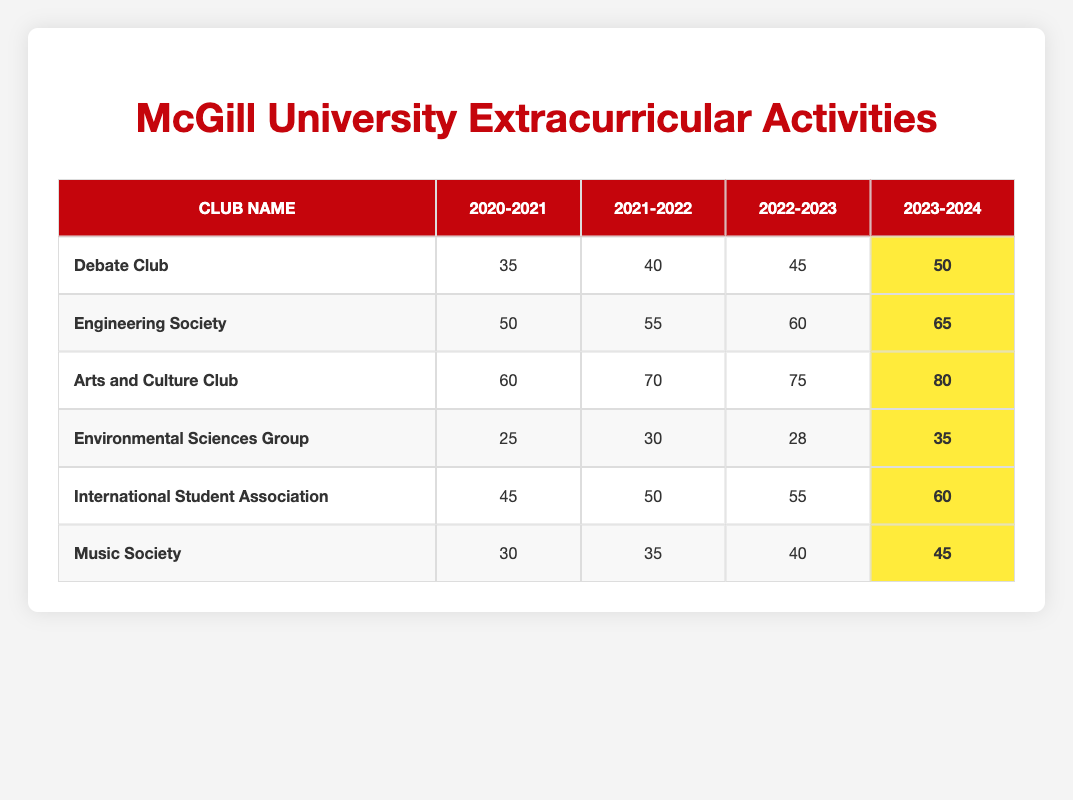What was the participation rate for the Arts and Culture Club in 2022-2023? The table shows that the participation rate for the Arts and Culture Club in 2022-2023 is listed as 75.
Answer: 75 Which club had the highest participation rate in 2023-2024? The table indicates that the Arts and Culture Club had the highest participation rate in 2023-2024 with a rate of 80.
Answer: Arts and Culture Club What was the increase in participation for the Debate Club from 2020-2021 to 2023-2024? The participation rates for the Debate Club are 35 (2020-2021) and 50 (2023-2024). The increase is calculated as 50 - 35, which equals 15.
Answer: 15 Did the Environmental Sciences Group have a participation rate above 30 in any academic year? The table shows that the Environmental Sciences Group had rates of 25 (2020-2021), 30 (2021-2022), 28 (2022-2023), and 35 (2023-2024). The only year it was above 30 was 2023-2024, when it was 35.
Answer: Yes What is the average participation rate of the Music Society over the years listed? The participation rates for the Music Society are 30 (2020-2021), 35 (2021-2022), 40 (2022-2023), and 45 (2023-2024). To calculate the average, sum these rates: 30 + 35 + 40 + 45 = 150, and then divide by 4, resulting in an average of 150/4 = 37.5.
Answer: 37.5 Which club showed the most significant growth in participation rates from 2020-2021 to 2023-2024? The growth for each club is calculated by subtracting the 2020-2021 rate from the 2023-2024 rate: Debate Club: 15, Engineering Society: 15, Arts and Culture Club: 20, Environmental Sciences Group: 10, International Student Association: 15, Music Society: 15. The most significant growth is for the Arts and Culture Club with an increase of 20.
Answer: Arts and Culture Club Was the participation rate for the International Student Association consistent throughout the years? Analyzing the participation rates: 45 (2020-2021), 50 (2021-2022), 55 (2022-2023), and 60 (2023-2024), it shows a steady increase each year. Thus, it can be concluded that it was consistent.
Answer: Yes What was the total participation rate for all clubs in the academic year 2021-2022? The participation rates for all clubs in 2021-2022 are: Debate Club (40), Engineering Society (55), Arts and Culture Club (70), Environmental Sciences Group (30), International Student Association (50), Music Society (35). Adding these together gives 40 + 55 + 70 + 30 + 50 + 35 = 280.
Answer: 280 